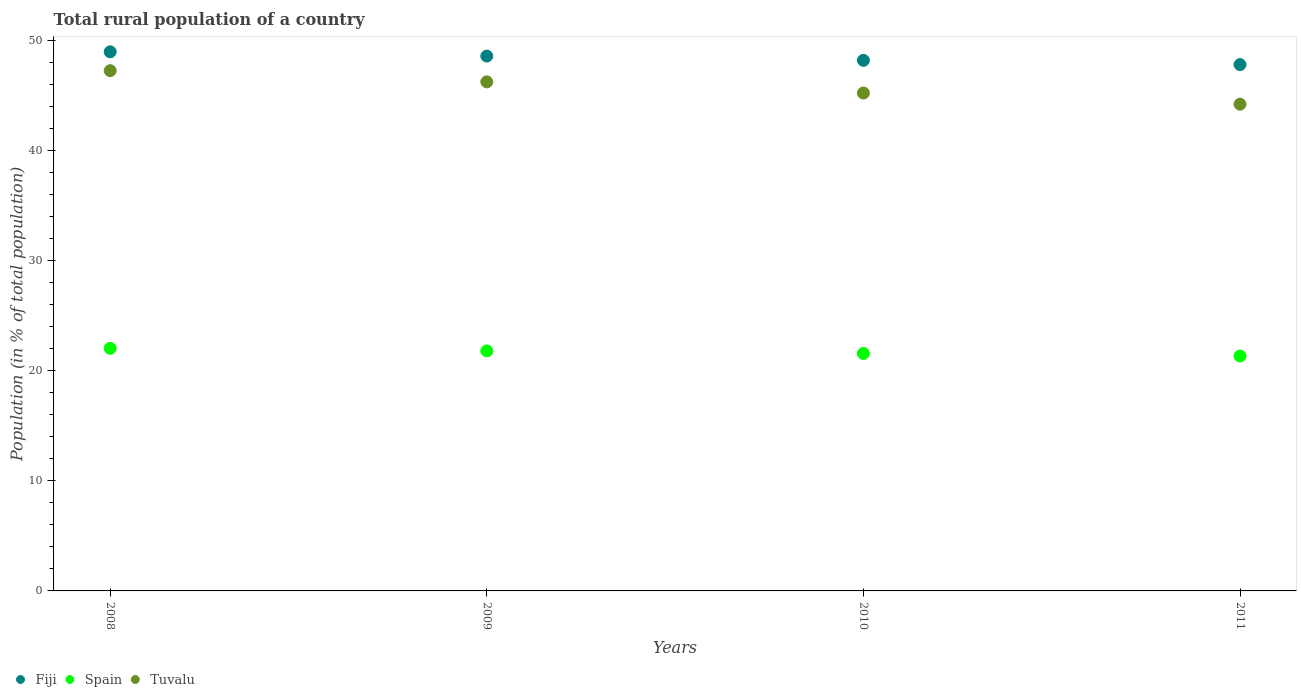Is the number of dotlines equal to the number of legend labels?
Ensure brevity in your answer.  Yes. What is the rural population in Spain in 2010?
Offer a terse response. 21.56. Across all years, what is the maximum rural population in Spain?
Your response must be concise. 22.02. Across all years, what is the minimum rural population in Fiji?
Make the answer very short. 47.79. In which year was the rural population in Fiji maximum?
Keep it short and to the point. 2008. In which year was the rural population in Fiji minimum?
Give a very brief answer. 2011. What is the total rural population in Spain in the graph?
Your answer should be very brief. 86.7. What is the difference between the rural population in Spain in 2008 and that in 2010?
Give a very brief answer. 0.47. What is the difference between the rural population in Tuvalu in 2009 and the rural population in Fiji in 2008?
Your response must be concise. -2.73. What is the average rural population in Tuvalu per year?
Your answer should be very brief. 45.71. In the year 2010, what is the difference between the rural population in Fiji and rural population in Spain?
Keep it short and to the point. 26.61. In how many years, is the rural population in Fiji greater than 22 %?
Ensure brevity in your answer.  4. What is the ratio of the rural population in Fiji in 2008 to that in 2011?
Give a very brief answer. 1.02. Is the rural population in Fiji in 2009 less than that in 2011?
Your answer should be compact. No. What is the difference between the highest and the second highest rural population in Spain?
Provide a short and direct response. 0.23. What is the difference between the highest and the lowest rural population in Fiji?
Offer a very short reply. 1.16. In how many years, is the rural population in Spain greater than the average rural population in Spain taken over all years?
Keep it short and to the point. 2. Does the rural population in Spain monotonically increase over the years?
Your answer should be compact. No. Is the rural population in Spain strictly greater than the rural population in Tuvalu over the years?
Your answer should be compact. No. Is the rural population in Spain strictly less than the rural population in Fiji over the years?
Give a very brief answer. Yes. How many dotlines are there?
Your response must be concise. 3. Does the graph contain any zero values?
Give a very brief answer. No. Where does the legend appear in the graph?
Offer a very short reply. Bottom left. How many legend labels are there?
Your response must be concise. 3. What is the title of the graph?
Ensure brevity in your answer.  Total rural population of a country. What is the label or title of the X-axis?
Offer a very short reply. Years. What is the label or title of the Y-axis?
Keep it short and to the point. Population (in % of total population). What is the Population (in % of total population) in Fiji in 2008?
Your answer should be compact. 48.95. What is the Population (in % of total population) in Spain in 2008?
Provide a short and direct response. 22.02. What is the Population (in % of total population) of Tuvalu in 2008?
Your answer should be very brief. 47.23. What is the Population (in % of total population) in Fiji in 2009?
Keep it short and to the point. 48.56. What is the Population (in % of total population) in Spain in 2009?
Provide a succinct answer. 21.79. What is the Population (in % of total population) of Tuvalu in 2009?
Provide a succinct answer. 46.22. What is the Population (in % of total population) of Fiji in 2010?
Offer a terse response. 48.17. What is the Population (in % of total population) of Spain in 2010?
Keep it short and to the point. 21.56. What is the Population (in % of total population) of Tuvalu in 2010?
Give a very brief answer. 45.2. What is the Population (in % of total population) of Fiji in 2011?
Your response must be concise. 47.79. What is the Population (in % of total population) of Spain in 2011?
Keep it short and to the point. 21.33. What is the Population (in % of total population) of Tuvalu in 2011?
Your answer should be very brief. 44.19. Across all years, what is the maximum Population (in % of total population) in Fiji?
Give a very brief answer. 48.95. Across all years, what is the maximum Population (in % of total population) in Spain?
Your response must be concise. 22.02. Across all years, what is the maximum Population (in % of total population) in Tuvalu?
Keep it short and to the point. 47.23. Across all years, what is the minimum Population (in % of total population) in Fiji?
Ensure brevity in your answer.  47.79. Across all years, what is the minimum Population (in % of total population) in Spain?
Make the answer very short. 21.33. Across all years, what is the minimum Population (in % of total population) of Tuvalu?
Your answer should be very brief. 44.19. What is the total Population (in % of total population) of Fiji in the graph?
Keep it short and to the point. 193.47. What is the total Population (in % of total population) of Spain in the graph?
Give a very brief answer. 86.7. What is the total Population (in % of total population) of Tuvalu in the graph?
Your answer should be compact. 182.85. What is the difference between the Population (in % of total population) of Fiji in 2008 and that in 2009?
Offer a terse response. 0.39. What is the difference between the Population (in % of total population) of Spain in 2008 and that in 2009?
Offer a very short reply. 0.23. What is the difference between the Population (in % of total population) in Fiji in 2008 and that in 2010?
Give a very brief answer. 0.78. What is the difference between the Population (in % of total population) of Spain in 2008 and that in 2010?
Your answer should be very brief. 0.47. What is the difference between the Population (in % of total population) of Tuvalu in 2008 and that in 2010?
Keep it short and to the point. 2.03. What is the difference between the Population (in % of total population) of Fiji in 2008 and that in 2011?
Your answer should be compact. 1.16. What is the difference between the Population (in % of total population) of Spain in 2008 and that in 2011?
Keep it short and to the point. 0.7. What is the difference between the Population (in % of total population) of Tuvalu in 2008 and that in 2011?
Your answer should be very brief. 3.04. What is the difference between the Population (in % of total population) in Fiji in 2009 and that in 2010?
Your response must be concise. 0.39. What is the difference between the Population (in % of total population) of Spain in 2009 and that in 2010?
Make the answer very short. 0.23. What is the difference between the Population (in % of total population) in Tuvalu in 2009 and that in 2010?
Keep it short and to the point. 1.01. What is the difference between the Population (in % of total population) in Fiji in 2009 and that in 2011?
Your answer should be very brief. 0.77. What is the difference between the Population (in % of total population) of Spain in 2009 and that in 2011?
Your answer should be very brief. 0.46. What is the difference between the Population (in % of total population) in Tuvalu in 2009 and that in 2011?
Your answer should be very brief. 2.02. What is the difference between the Population (in % of total population) in Fiji in 2010 and that in 2011?
Ensure brevity in your answer.  0.39. What is the difference between the Population (in % of total population) in Spain in 2010 and that in 2011?
Give a very brief answer. 0.23. What is the difference between the Population (in % of total population) of Fiji in 2008 and the Population (in % of total population) of Spain in 2009?
Offer a terse response. 27.16. What is the difference between the Population (in % of total population) of Fiji in 2008 and the Population (in % of total population) of Tuvalu in 2009?
Your answer should be compact. 2.73. What is the difference between the Population (in % of total population) in Spain in 2008 and the Population (in % of total population) in Tuvalu in 2009?
Provide a short and direct response. -24.19. What is the difference between the Population (in % of total population) of Fiji in 2008 and the Population (in % of total population) of Spain in 2010?
Offer a terse response. 27.39. What is the difference between the Population (in % of total population) in Fiji in 2008 and the Population (in % of total population) in Tuvalu in 2010?
Provide a short and direct response. 3.75. What is the difference between the Population (in % of total population) in Spain in 2008 and the Population (in % of total population) in Tuvalu in 2010?
Provide a short and direct response. -23.18. What is the difference between the Population (in % of total population) of Fiji in 2008 and the Population (in % of total population) of Spain in 2011?
Your answer should be compact. 27.62. What is the difference between the Population (in % of total population) in Fiji in 2008 and the Population (in % of total population) in Tuvalu in 2011?
Provide a succinct answer. 4.76. What is the difference between the Population (in % of total population) in Spain in 2008 and the Population (in % of total population) in Tuvalu in 2011?
Provide a succinct answer. -22.17. What is the difference between the Population (in % of total population) in Fiji in 2009 and the Population (in % of total population) in Spain in 2010?
Provide a short and direct response. 27. What is the difference between the Population (in % of total population) of Fiji in 2009 and the Population (in % of total population) of Tuvalu in 2010?
Make the answer very short. 3.36. What is the difference between the Population (in % of total population) in Spain in 2009 and the Population (in % of total population) in Tuvalu in 2010?
Your answer should be very brief. -23.41. What is the difference between the Population (in % of total population) in Fiji in 2009 and the Population (in % of total population) in Spain in 2011?
Make the answer very short. 27.23. What is the difference between the Population (in % of total population) in Fiji in 2009 and the Population (in % of total population) in Tuvalu in 2011?
Ensure brevity in your answer.  4.37. What is the difference between the Population (in % of total population) of Spain in 2009 and the Population (in % of total population) of Tuvalu in 2011?
Give a very brief answer. -22.4. What is the difference between the Population (in % of total population) of Fiji in 2010 and the Population (in % of total population) of Spain in 2011?
Make the answer very short. 26.84. What is the difference between the Population (in % of total population) of Fiji in 2010 and the Population (in % of total population) of Tuvalu in 2011?
Keep it short and to the point. 3.98. What is the difference between the Population (in % of total population) of Spain in 2010 and the Population (in % of total population) of Tuvalu in 2011?
Ensure brevity in your answer.  -22.64. What is the average Population (in % of total population) of Fiji per year?
Offer a terse response. 48.37. What is the average Population (in % of total population) in Spain per year?
Offer a terse response. 21.67. What is the average Population (in % of total population) in Tuvalu per year?
Make the answer very short. 45.71. In the year 2008, what is the difference between the Population (in % of total population) of Fiji and Population (in % of total population) of Spain?
Your answer should be compact. 26.93. In the year 2008, what is the difference between the Population (in % of total population) of Fiji and Population (in % of total population) of Tuvalu?
Make the answer very short. 1.71. In the year 2008, what is the difference between the Population (in % of total population) of Spain and Population (in % of total population) of Tuvalu?
Ensure brevity in your answer.  -25.21. In the year 2009, what is the difference between the Population (in % of total population) of Fiji and Population (in % of total population) of Spain?
Give a very brief answer. 26.77. In the year 2009, what is the difference between the Population (in % of total population) of Fiji and Population (in % of total population) of Tuvalu?
Give a very brief answer. 2.34. In the year 2009, what is the difference between the Population (in % of total population) of Spain and Population (in % of total population) of Tuvalu?
Your answer should be compact. -24.43. In the year 2010, what is the difference between the Population (in % of total population) of Fiji and Population (in % of total population) of Spain?
Provide a succinct answer. 26.61. In the year 2010, what is the difference between the Population (in % of total population) of Fiji and Population (in % of total population) of Tuvalu?
Keep it short and to the point. 2.97. In the year 2010, what is the difference between the Population (in % of total population) in Spain and Population (in % of total population) in Tuvalu?
Give a very brief answer. -23.65. In the year 2011, what is the difference between the Population (in % of total population) of Fiji and Population (in % of total population) of Spain?
Your answer should be compact. 26.46. In the year 2011, what is the difference between the Population (in % of total population) of Fiji and Population (in % of total population) of Tuvalu?
Offer a very short reply. 3.59. In the year 2011, what is the difference between the Population (in % of total population) in Spain and Population (in % of total population) in Tuvalu?
Make the answer very short. -22.87. What is the ratio of the Population (in % of total population) of Spain in 2008 to that in 2009?
Offer a very short reply. 1.01. What is the ratio of the Population (in % of total population) in Tuvalu in 2008 to that in 2009?
Make the answer very short. 1.02. What is the ratio of the Population (in % of total population) of Fiji in 2008 to that in 2010?
Offer a terse response. 1.02. What is the ratio of the Population (in % of total population) of Spain in 2008 to that in 2010?
Provide a short and direct response. 1.02. What is the ratio of the Population (in % of total population) of Tuvalu in 2008 to that in 2010?
Your answer should be compact. 1.04. What is the ratio of the Population (in % of total population) of Fiji in 2008 to that in 2011?
Keep it short and to the point. 1.02. What is the ratio of the Population (in % of total population) of Spain in 2008 to that in 2011?
Give a very brief answer. 1.03. What is the ratio of the Population (in % of total population) of Tuvalu in 2008 to that in 2011?
Ensure brevity in your answer.  1.07. What is the ratio of the Population (in % of total population) in Spain in 2009 to that in 2010?
Provide a succinct answer. 1.01. What is the ratio of the Population (in % of total population) of Tuvalu in 2009 to that in 2010?
Keep it short and to the point. 1.02. What is the ratio of the Population (in % of total population) in Fiji in 2009 to that in 2011?
Offer a terse response. 1.02. What is the ratio of the Population (in % of total population) of Spain in 2009 to that in 2011?
Offer a very short reply. 1.02. What is the ratio of the Population (in % of total population) in Tuvalu in 2009 to that in 2011?
Keep it short and to the point. 1.05. What is the ratio of the Population (in % of total population) in Spain in 2010 to that in 2011?
Your response must be concise. 1.01. What is the ratio of the Population (in % of total population) of Tuvalu in 2010 to that in 2011?
Your answer should be compact. 1.02. What is the difference between the highest and the second highest Population (in % of total population) in Fiji?
Keep it short and to the point. 0.39. What is the difference between the highest and the second highest Population (in % of total population) of Spain?
Give a very brief answer. 0.23. What is the difference between the highest and the lowest Population (in % of total population) in Fiji?
Your response must be concise. 1.16. What is the difference between the highest and the lowest Population (in % of total population) in Spain?
Offer a terse response. 0.7. What is the difference between the highest and the lowest Population (in % of total population) in Tuvalu?
Give a very brief answer. 3.04. 